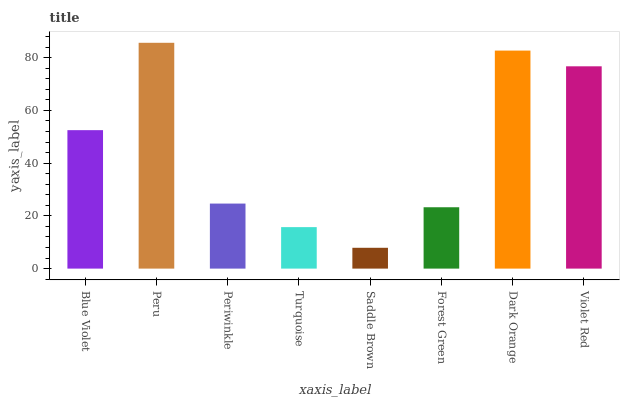Is Saddle Brown the minimum?
Answer yes or no. Yes. Is Peru the maximum?
Answer yes or no. Yes. Is Periwinkle the minimum?
Answer yes or no. No. Is Periwinkle the maximum?
Answer yes or no. No. Is Peru greater than Periwinkle?
Answer yes or no. Yes. Is Periwinkle less than Peru?
Answer yes or no. Yes. Is Periwinkle greater than Peru?
Answer yes or no. No. Is Peru less than Periwinkle?
Answer yes or no. No. Is Blue Violet the high median?
Answer yes or no. Yes. Is Periwinkle the low median?
Answer yes or no. Yes. Is Dark Orange the high median?
Answer yes or no. No. Is Turquoise the low median?
Answer yes or no. No. 